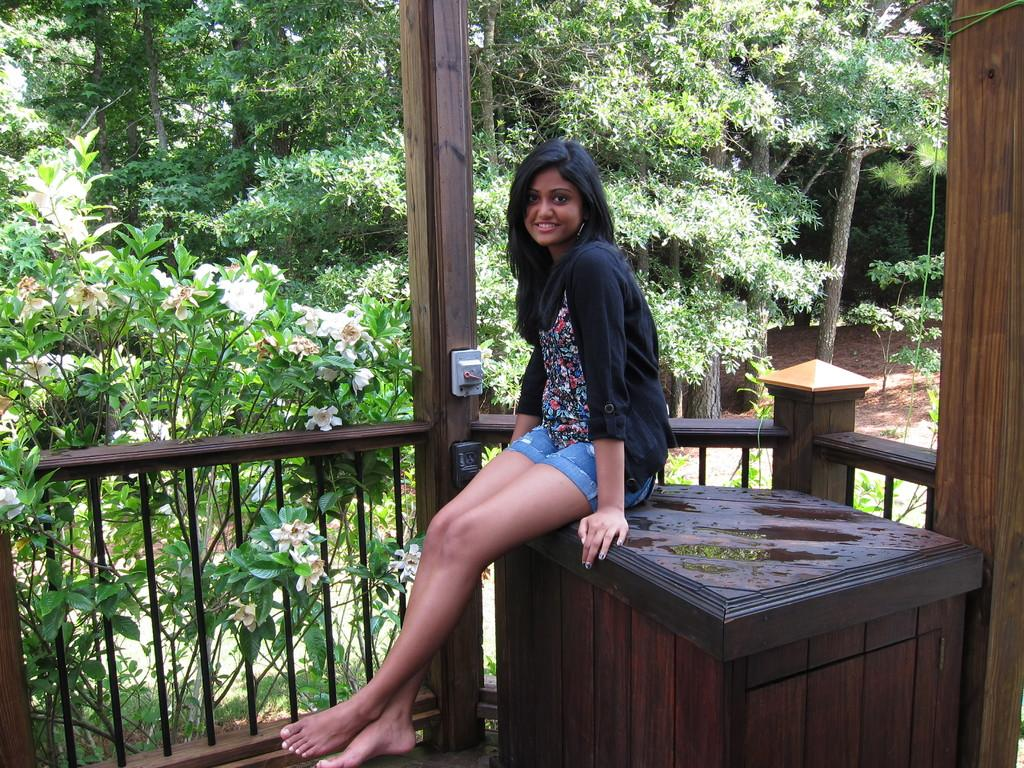Who is the main subject in the image? There is a woman in the image. What is the woman doing in the image? The woman is posing for the camera. Where is the woman sitting in the image? The woman is sitting on furniture. What can be seen in the background of the image? There are plants in the background of the image. What does the woman need in the image? There is no information about the woman's needs in the image. --- Facts: 1. There is a car in the image. 2. The car is red. 3. The car has four wheels. 4. The car is parked on the street. Absurd Topics: unicorn, rainbow, stars Conversation: What is the main subject in the image? There is a car in the image. What color is the car? The car is red. How many wheels does the car have? The car has four wheels. Where is the car located in the image? The car is parked on the street. Reasoning: Let's think step by step in order to ${produce the conversation}. We start by identifying the main subject of the image, which is the car. Next, we describe specific features of the car, such as the color and the number of wheels. Then, we observe the car's location, noting that it is parked on the street. Absurd Question/Answer: How many unicorns can be seen playing with the rainbow in the image? There are no unicorns or rainbows present in the image. --- Facts: 1. There is a group of people in the image. 2. The people are wearing hats. 3. The people are holding hands. 4. The people are standing in a circle. Absurd Topics: elephant, jungle, trunk Conversation: How many people are in the image? There is a group of people in the image. What are the people wearing on their heads? The people are wearing hats. What are the people doing with their hands? The people are holding hands. How are the people positioned in the image? The people are standing in a circle. Reasoning: Let's think step by step in order to ${produce the conversation}. We start by identifying the main subjects of the image, which are the group of people. Next, we describe specific features of the people, such as the hats they are wearing. Then, we observe the actions of the people, noting that they are holding hands. Finally, we describe the formation of the people in the image, which is a circle. Absurd Question/Answer: Can you see any elephants in the image? There are no elephants present in the image. --- Facts: 1. There is a large tree in the image. 2. The tree has green leaves 